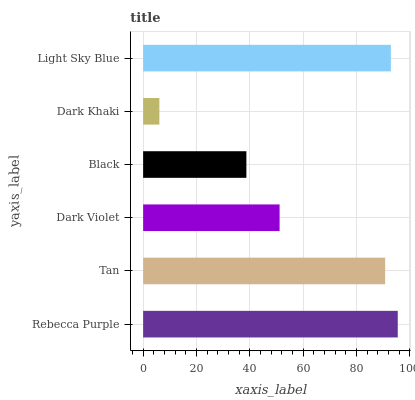Is Dark Khaki the minimum?
Answer yes or no. Yes. Is Rebecca Purple the maximum?
Answer yes or no. Yes. Is Tan the minimum?
Answer yes or no. No. Is Tan the maximum?
Answer yes or no. No. Is Rebecca Purple greater than Tan?
Answer yes or no. Yes. Is Tan less than Rebecca Purple?
Answer yes or no. Yes. Is Tan greater than Rebecca Purple?
Answer yes or no. No. Is Rebecca Purple less than Tan?
Answer yes or no. No. Is Tan the high median?
Answer yes or no. Yes. Is Dark Violet the low median?
Answer yes or no. Yes. Is Rebecca Purple the high median?
Answer yes or no. No. Is Dark Khaki the low median?
Answer yes or no. No. 